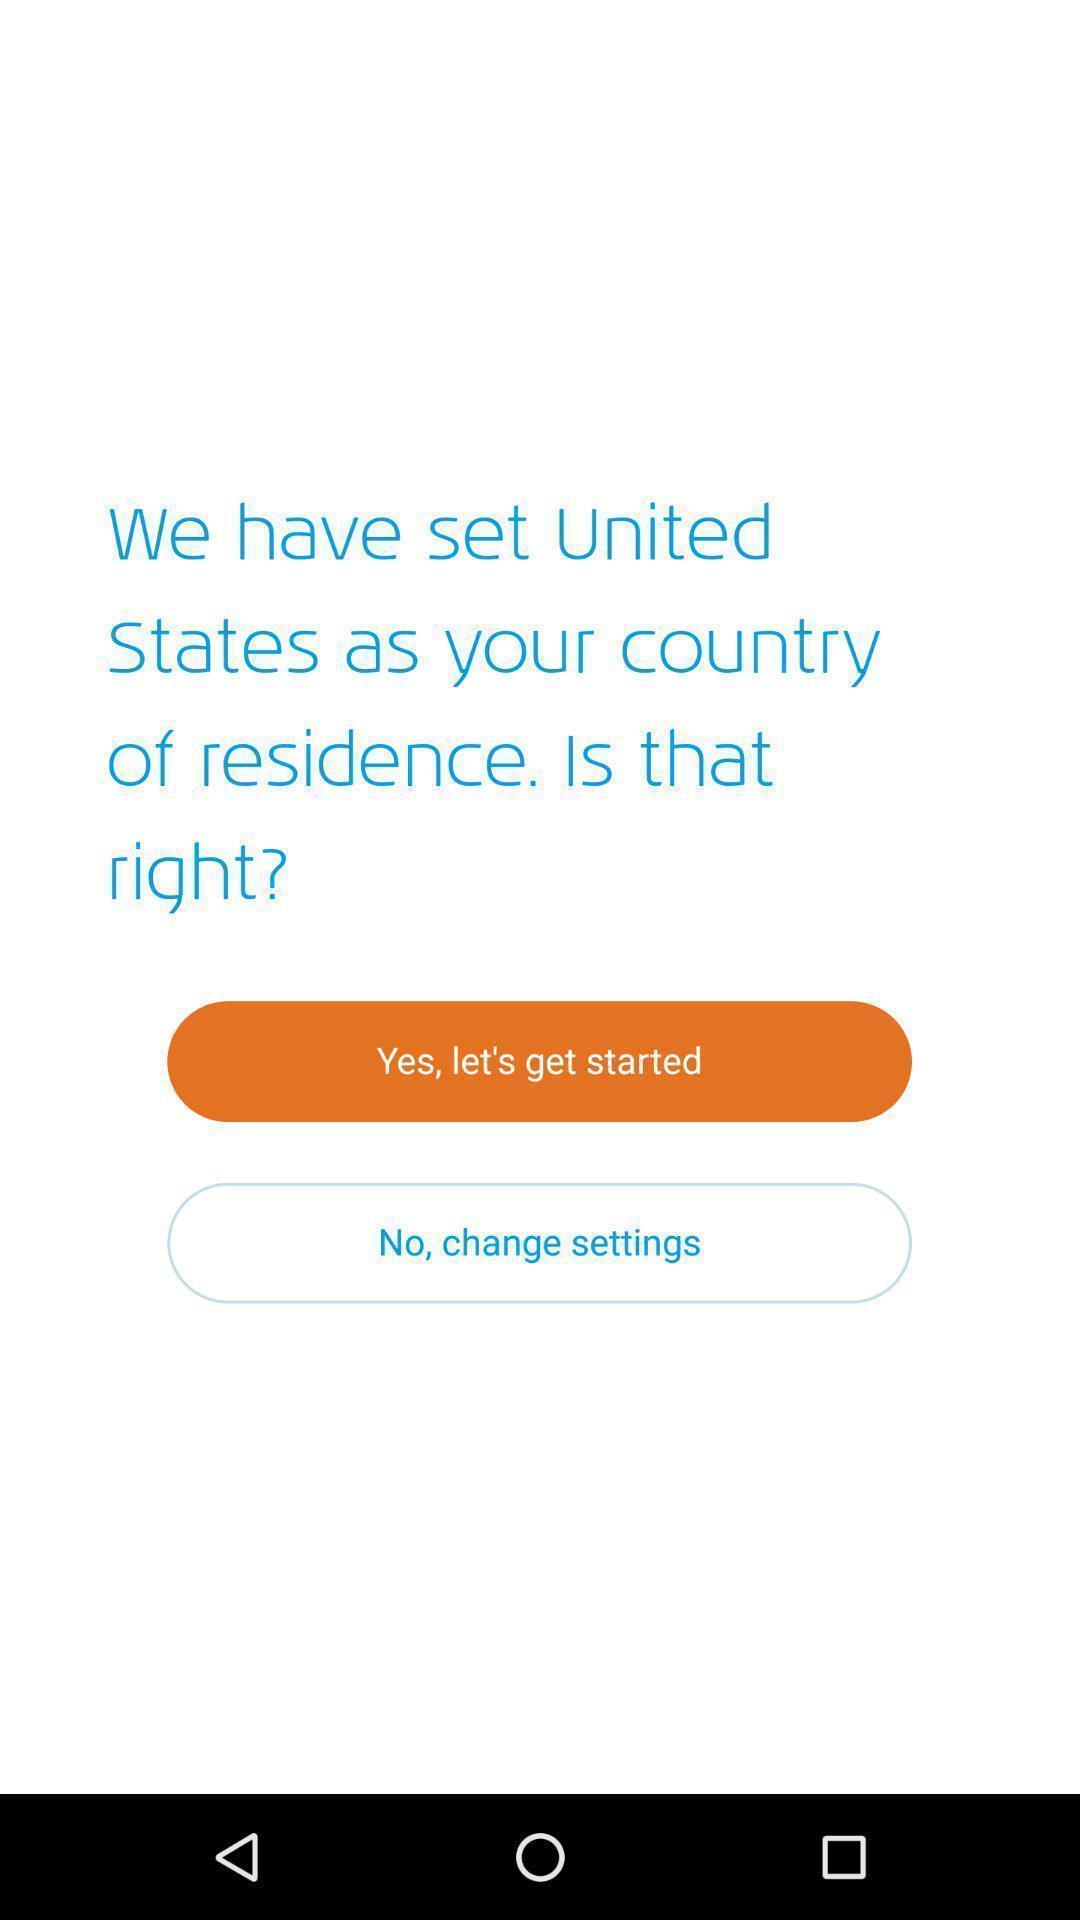What is the overall content of this screenshot? Window displaying a flight app. 